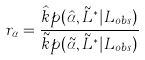Convert formula to latex. <formula><loc_0><loc_0><loc_500><loc_500>r _ { \alpha } = \frac { \hat { k } p ( \hat { \alpha } , \tilde { L } ^ { * } | L _ { o b s } ) } { \tilde { k } p ( \tilde { \alpha } , \tilde { L } ^ { * } | L _ { o b s } ) }</formula> 